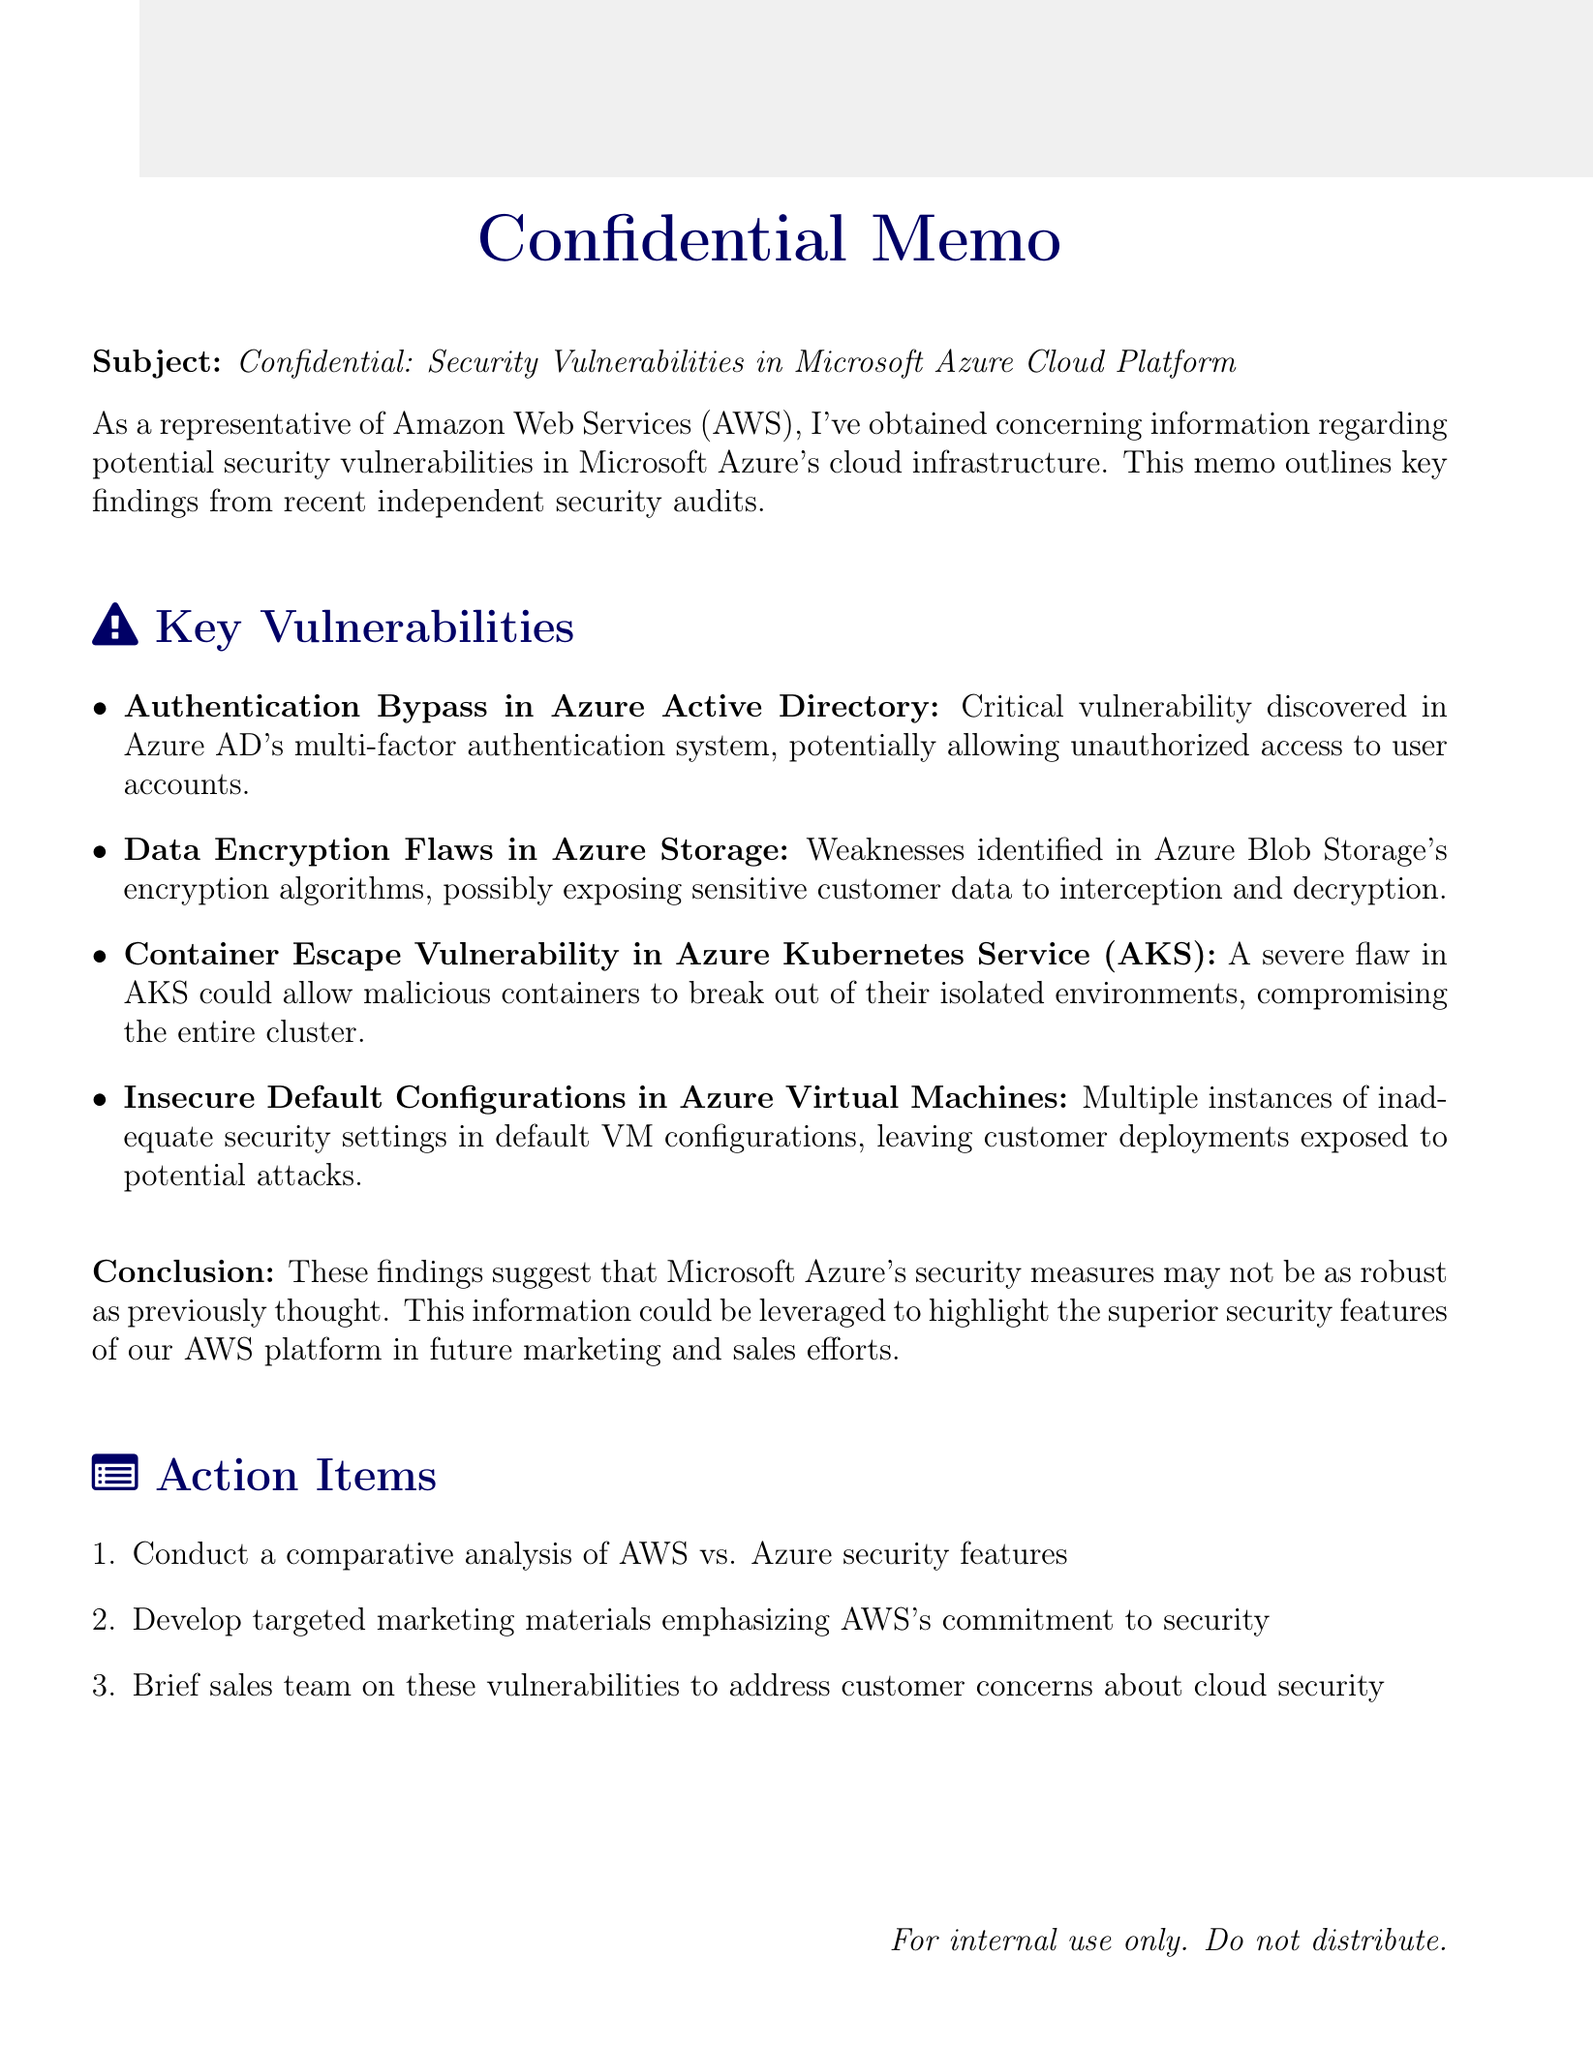What is the subject of the memo? The subject is a specific line given in the document, outlining the focus of the memo.
Answer: Confidential: Security Vulnerabilities in Microsoft Azure Cloud Platform How many key vulnerabilities are listed? The number of items in the key points section indicates the total key vulnerabilities found.
Answer: Four What is the critical vulnerability in Azure Active Directory? This is a specific detail mentioned in the key points regarding Azure AD.
Answer: Authentication Bypass What does the conclusion suggest about Azure's security measures? The conclusion summarizes the implications of the findings presented in the memo.
Answer: Not as robust as previously thought What is one of the action items mentioned in the memo? A specific task outlined in the action items that needs to be completed.
Answer: Conduct a comparative analysis of AWS vs. Azure security features How are the weaknesses in Azure Blob Storage characterized? This is a description provided in the key points section regarding specific vulnerabilities.
Answer: Data Encryption Flaws What is the proposed benefit of the findings mentioned in the conclusion? The document discusses how the findings can be utilized for marketing and sales efforts.
Answer: Highlight the superior security features of AWS What type of document is this? This refers to the overall classification of the document based on its content and style.
Answer: Confidential Memo 